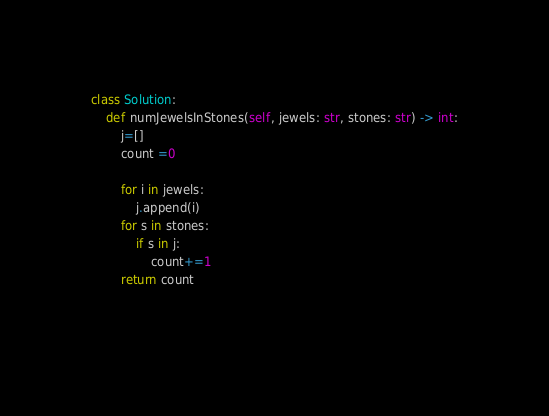<code> <loc_0><loc_0><loc_500><loc_500><_Python_>class Solution:
    def numJewelsInStones(self, jewels: str, stones: str) -> int:
        j=[]
        count =0
        
        for i in jewels: 
            j.append(i)
        for s in stones: 
            if s in j: 
                count+=1
        return count 
  
    </code> 